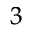Convert formula to latex. <formula><loc_0><loc_0><loc_500><loc_500>^ { 3 }</formula> 